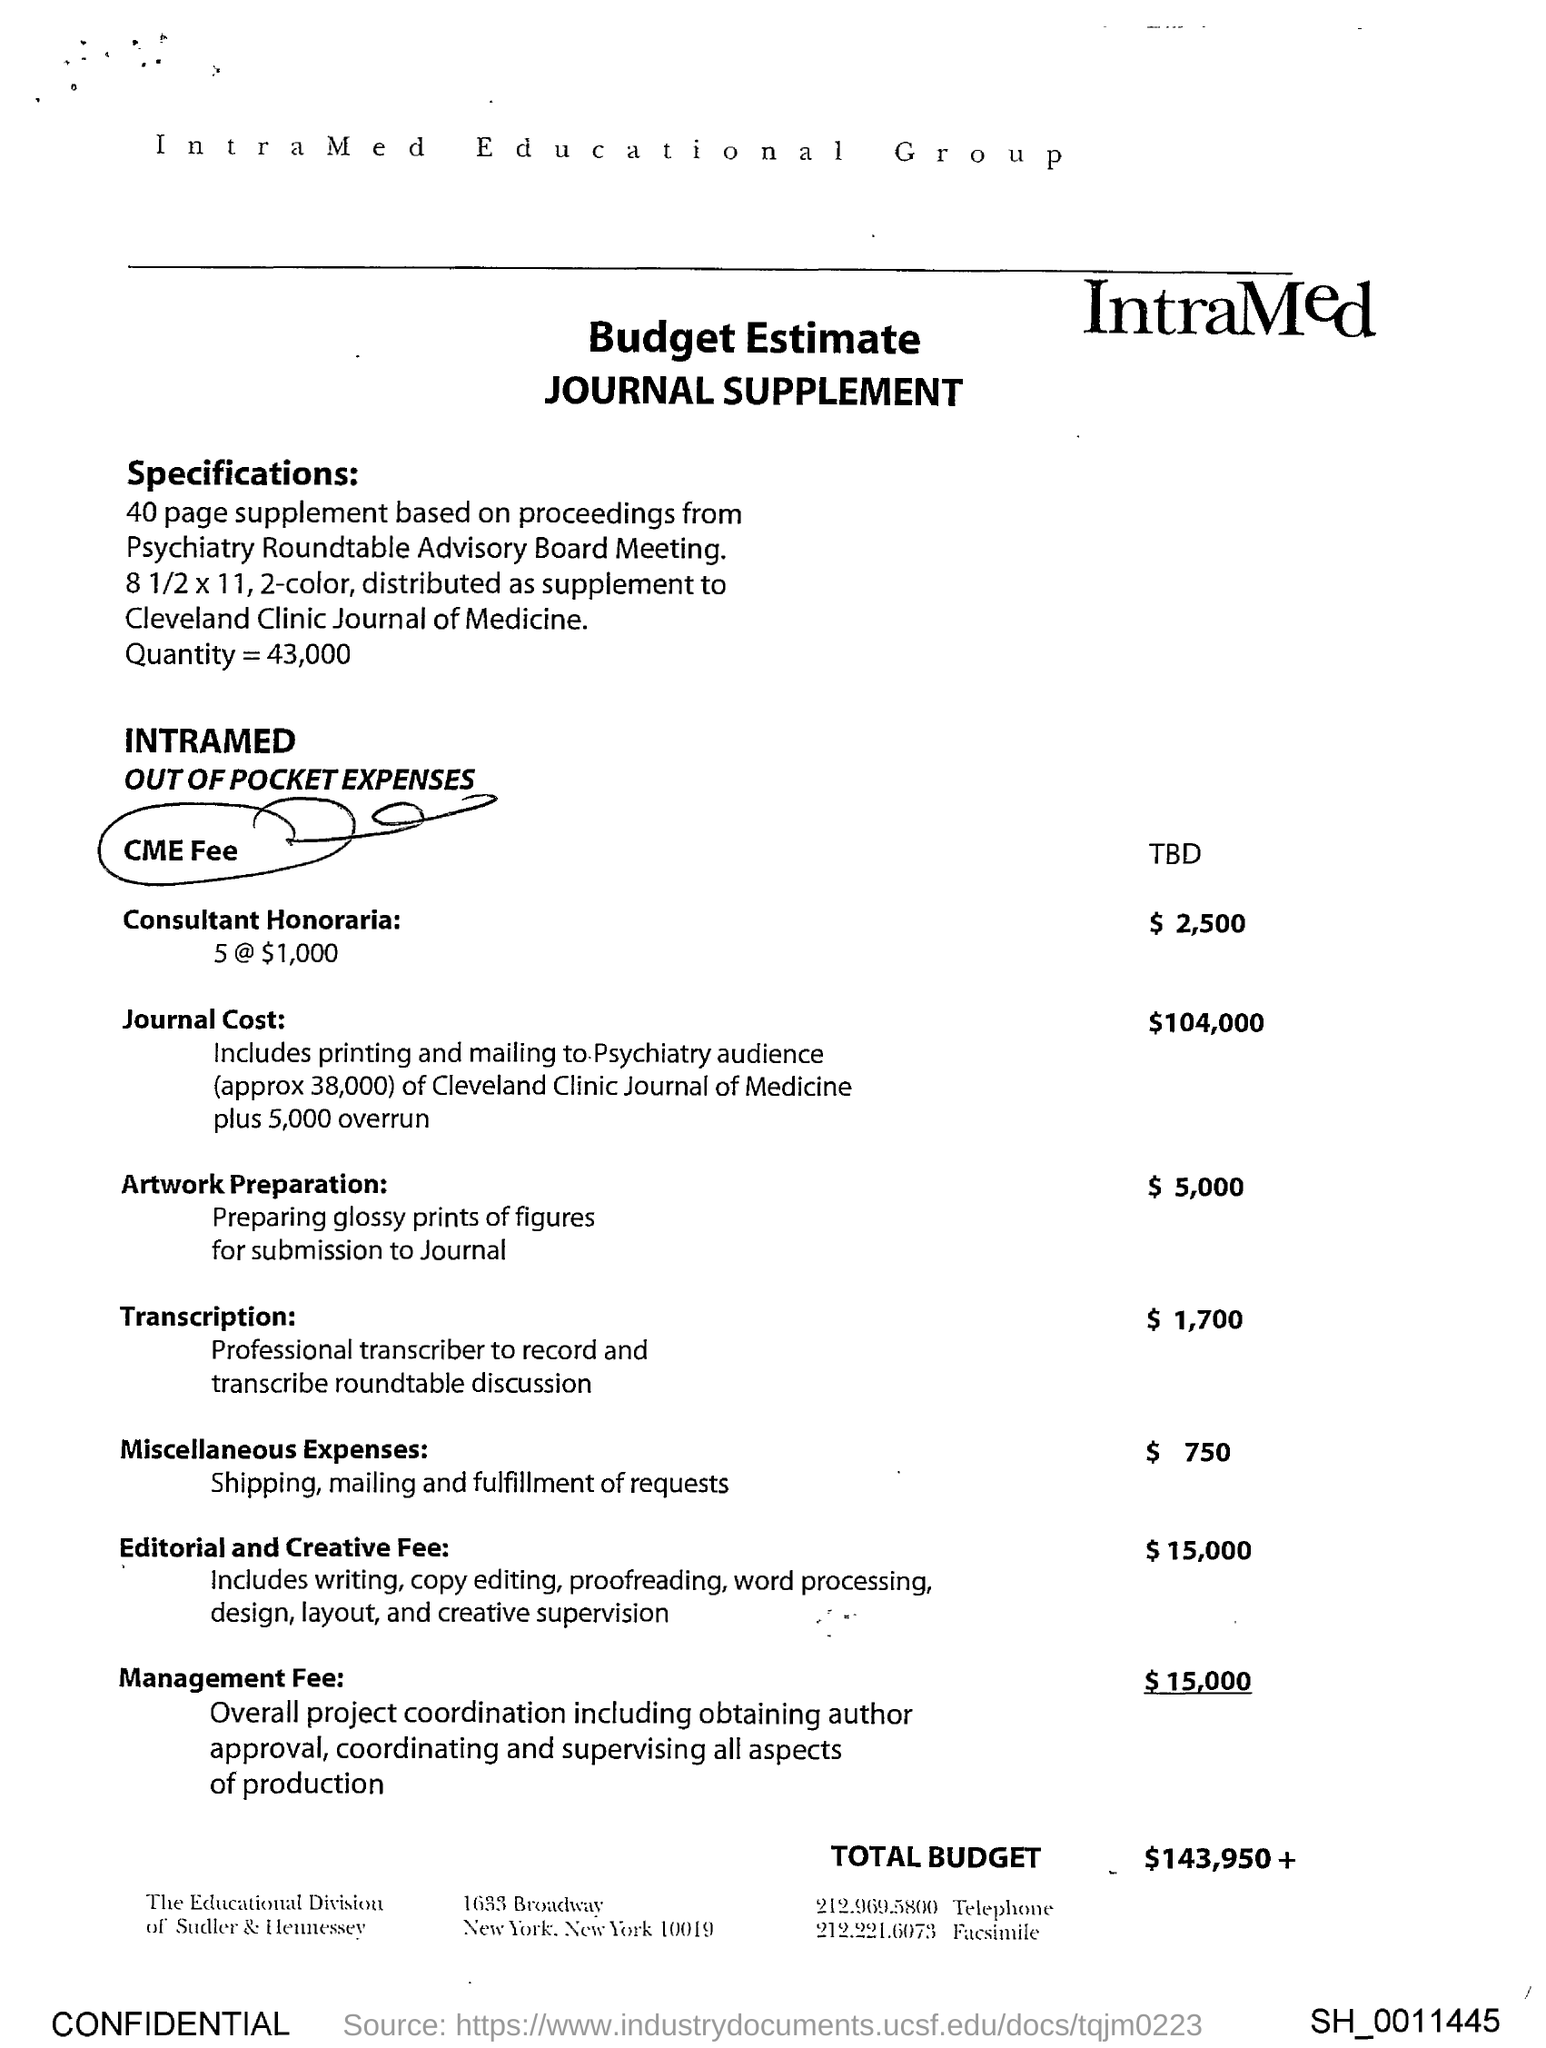What is the CME Fee?
Ensure brevity in your answer.  TBD. What is the Consultant Honoraria?
Your response must be concise. $2,500. What is the Journal cost?
Make the answer very short. $104,000. What is the Editorial and Creative Fee?
Provide a succinct answer. $15,000. What is the Management Fee?
Provide a short and direct response. $15,000. What is the Total Budget?
Your answer should be compact. $143,950. What is the Telephone?
Offer a terse response. 212.969.5800. 